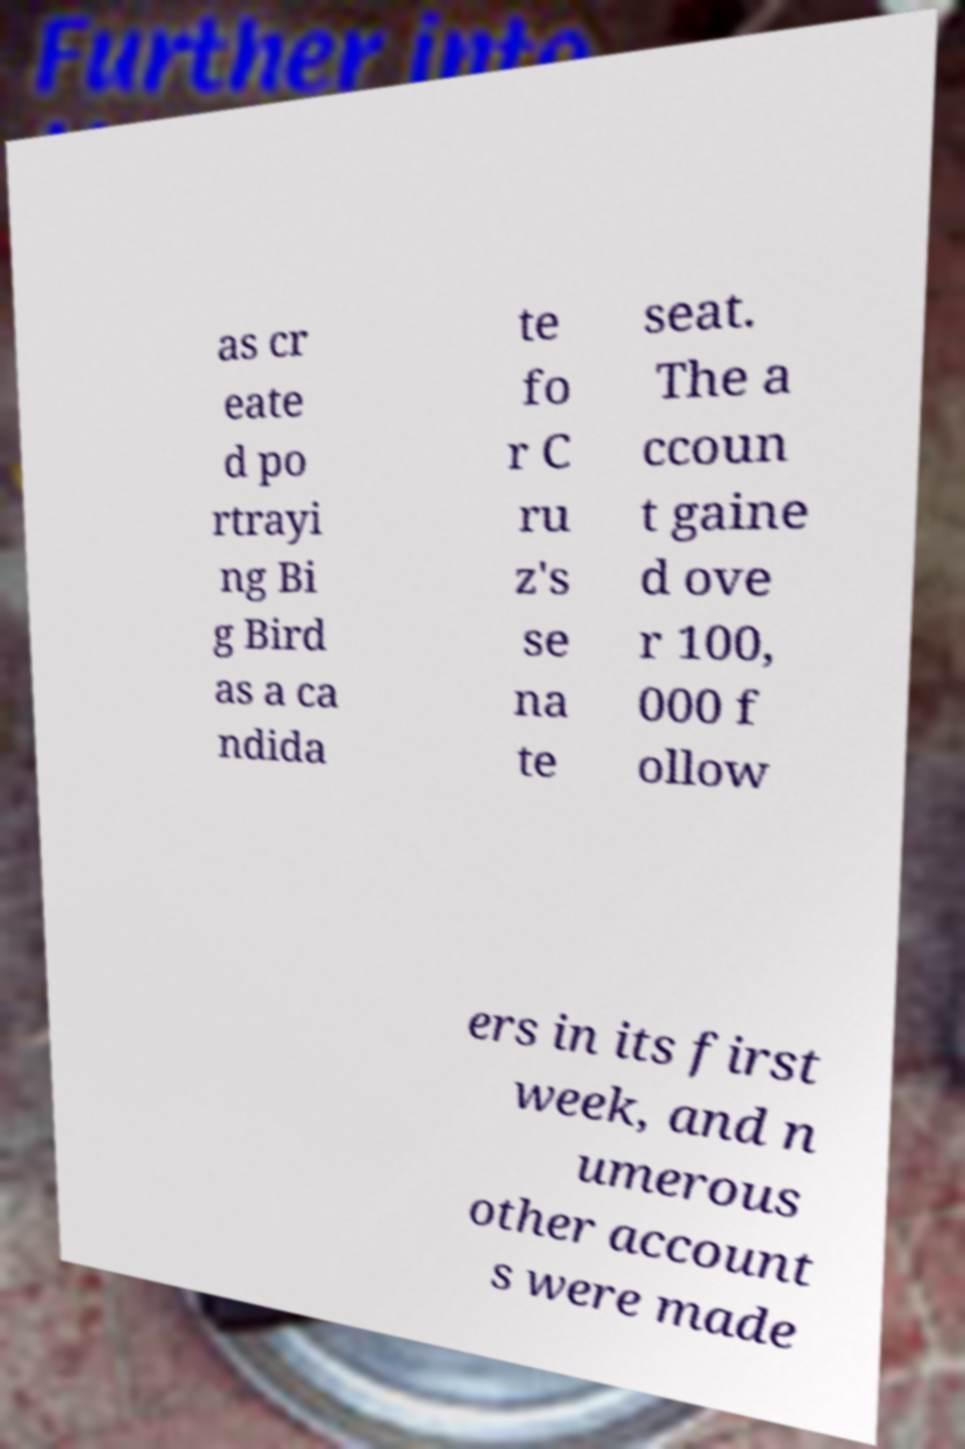Can you read and provide the text displayed in the image?This photo seems to have some interesting text. Can you extract and type it out for me? as cr eate d po rtrayi ng Bi g Bird as a ca ndida te fo r C ru z's se na te seat. The a ccoun t gaine d ove r 100, 000 f ollow ers in its first week, and n umerous other account s were made 